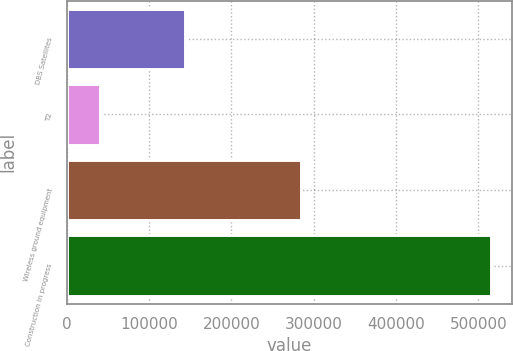Convert chart to OTSL. <chart><loc_0><loc_0><loc_500><loc_500><bar_chart><fcel>DBS Satellites<fcel>T2<fcel>Wireless ground equipment<fcel>Construction in progress<nl><fcel>143839<fcel>40000<fcel>284902<fcel>515447<nl></chart> 